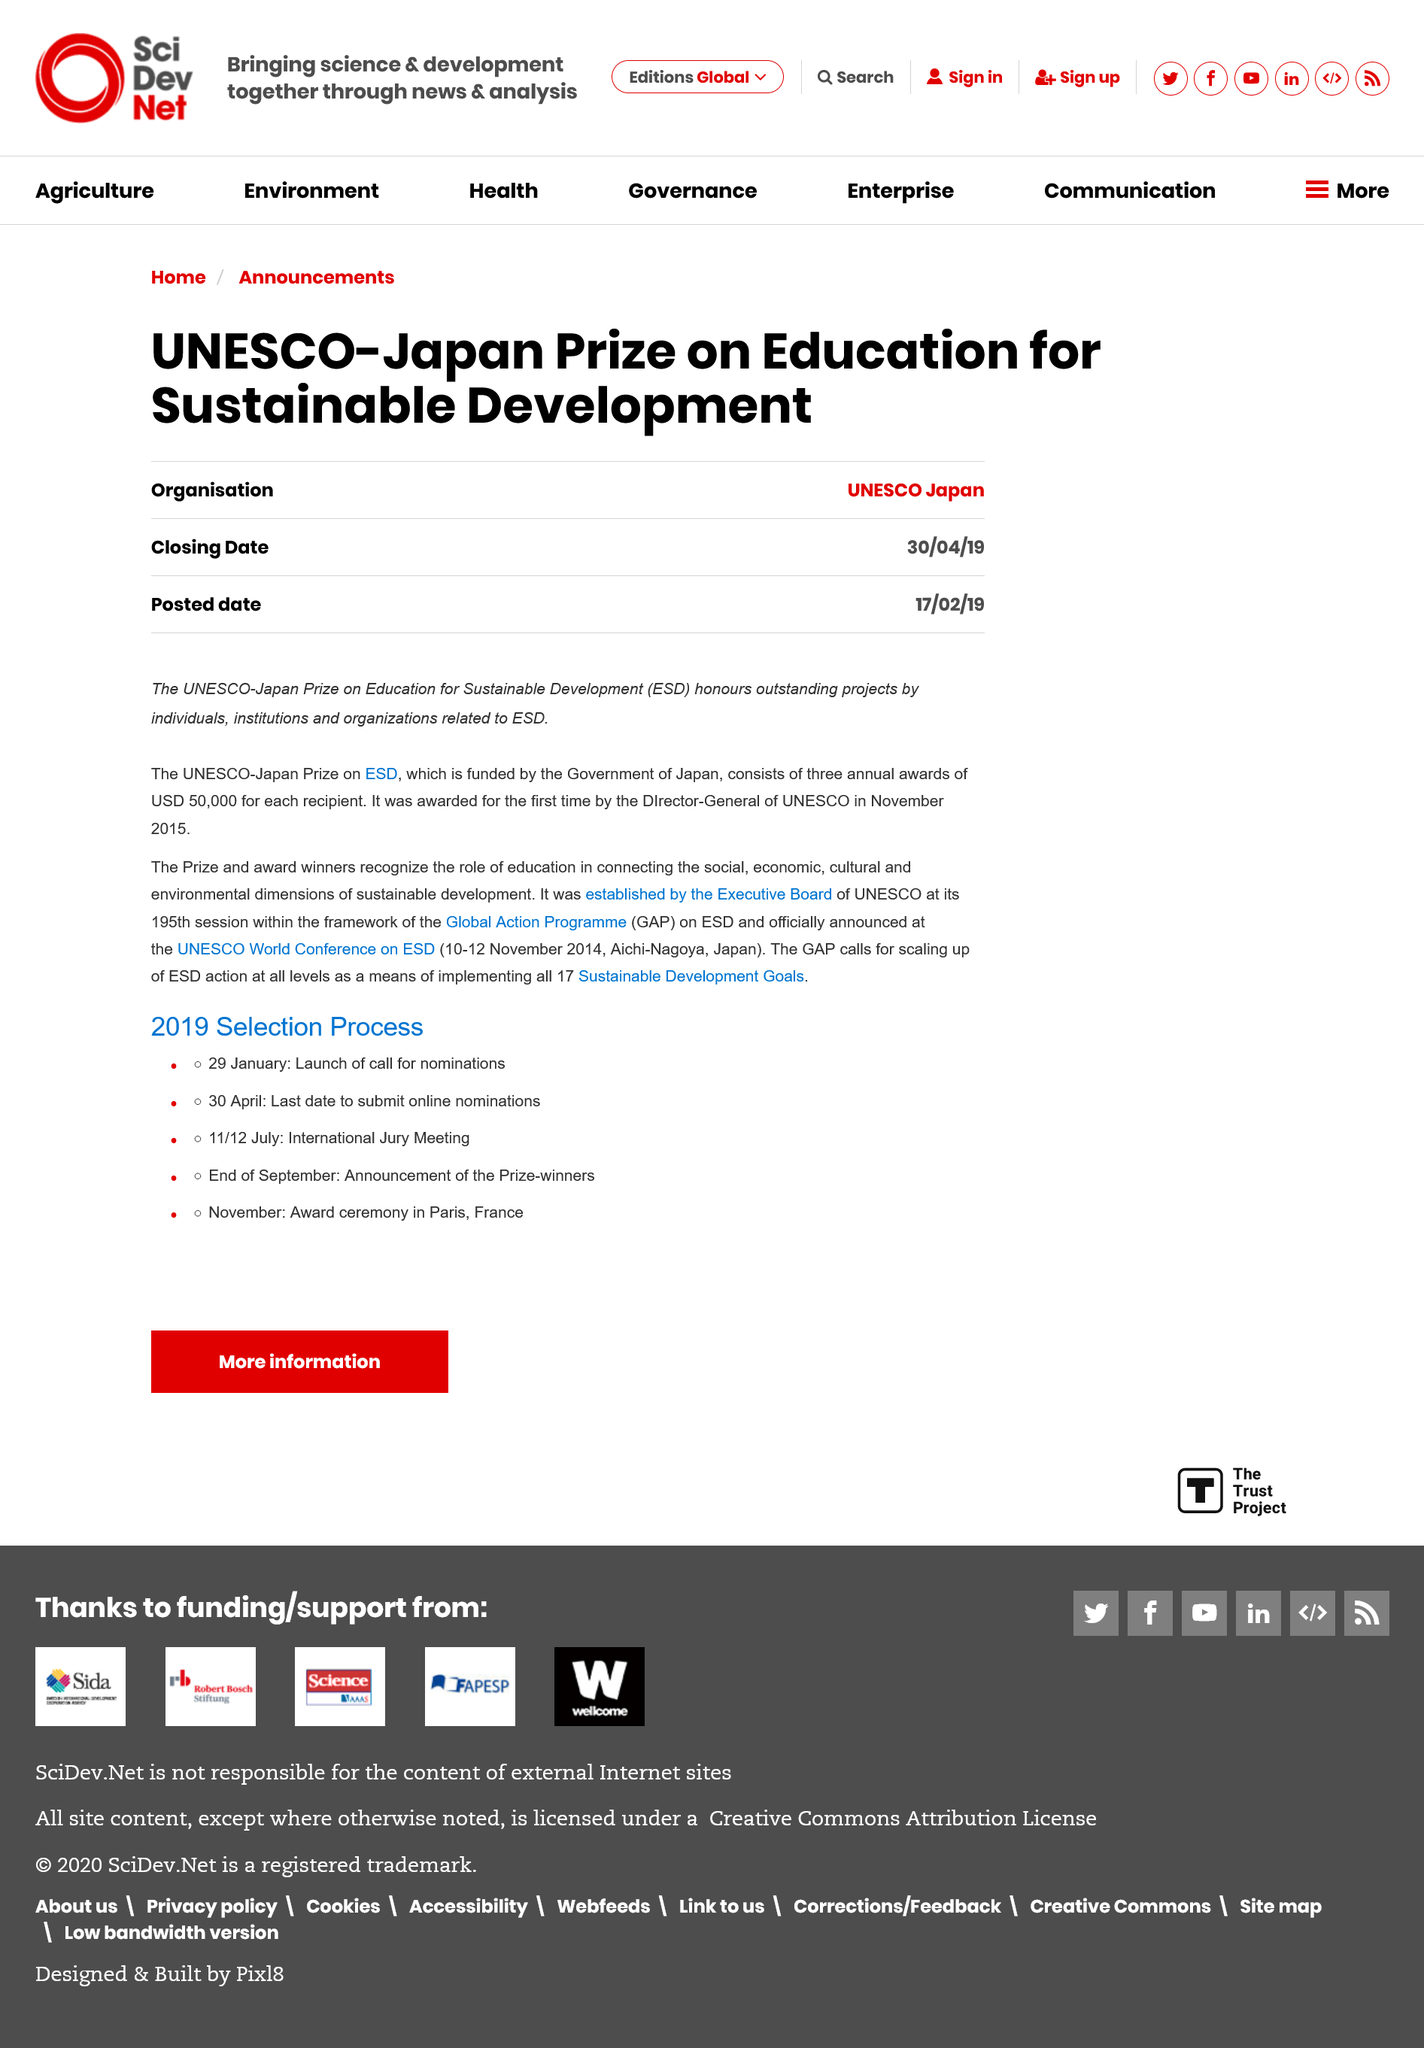Indicate a few pertinent items in this graphic. The prize and award winners recognize the critical role of education in connecting the social, economic, cultural, and environmental dimensions of sustainable development, and the importance of recognizing the interconnections between these dimensions. The UNESCO-Japan Prize on Education for Sustainable Development honors exceptional projects by individuals, institutions, and organizations that are related to ESD. The UNESCO-Japan Prize on Education for Sustainable Development is funded entirely by the Government of Japan. 